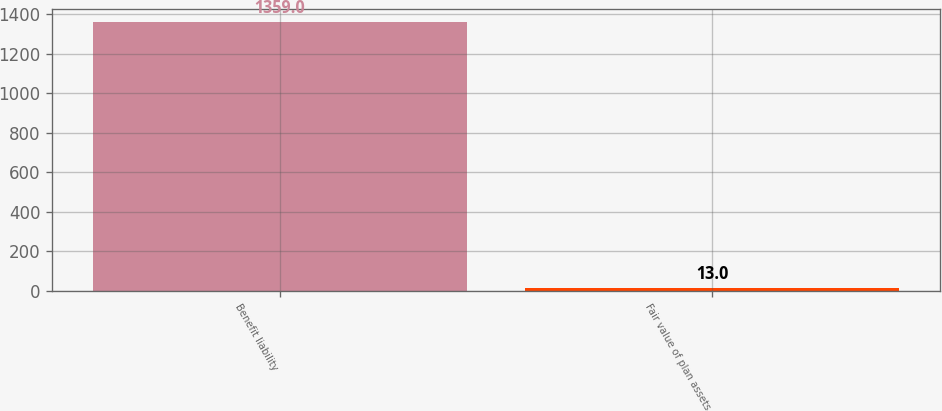Convert chart to OTSL. <chart><loc_0><loc_0><loc_500><loc_500><bar_chart><fcel>Benefit liability<fcel>Fair value of plan assets<nl><fcel>1359<fcel>13<nl></chart> 